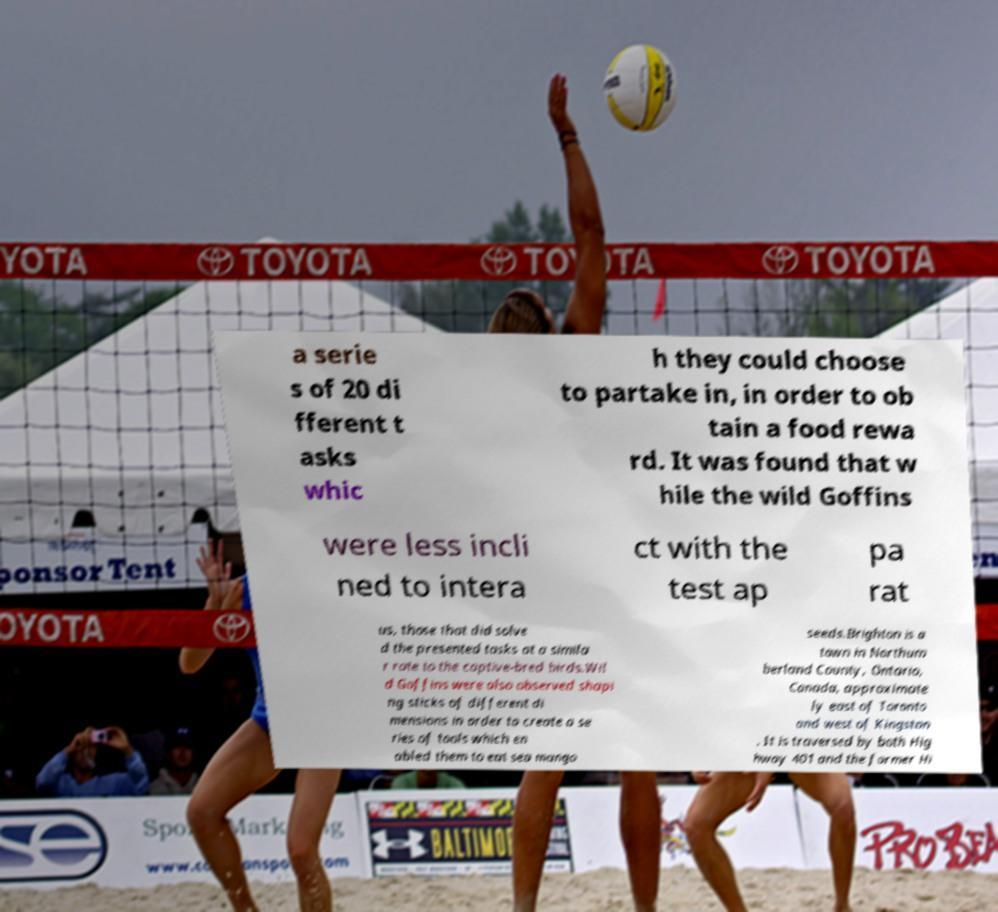What messages or text are displayed in this image? I need them in a readable, typed format. a serie s of 20 di fferent t asks whic h they could choose to partake in, in order to ob tain a food rewa rd. It was found that w hile the wild Goffins were less incli ned to intera ct with the test ap pa rat us, those that did solve d the presented tasks at a simila r rate to the captive-bred birds.Wil d Goffins were also observed shapi ng sticks of different di mensions in order to create a se ries of tools which en abled them to eat sea mango seeds.Brighton is a town in Northum berland County, Ontario, Canada, approximate ly east of Toronto and west of Kingston . It is traversed by both Hig hway 401 and the former Hi 